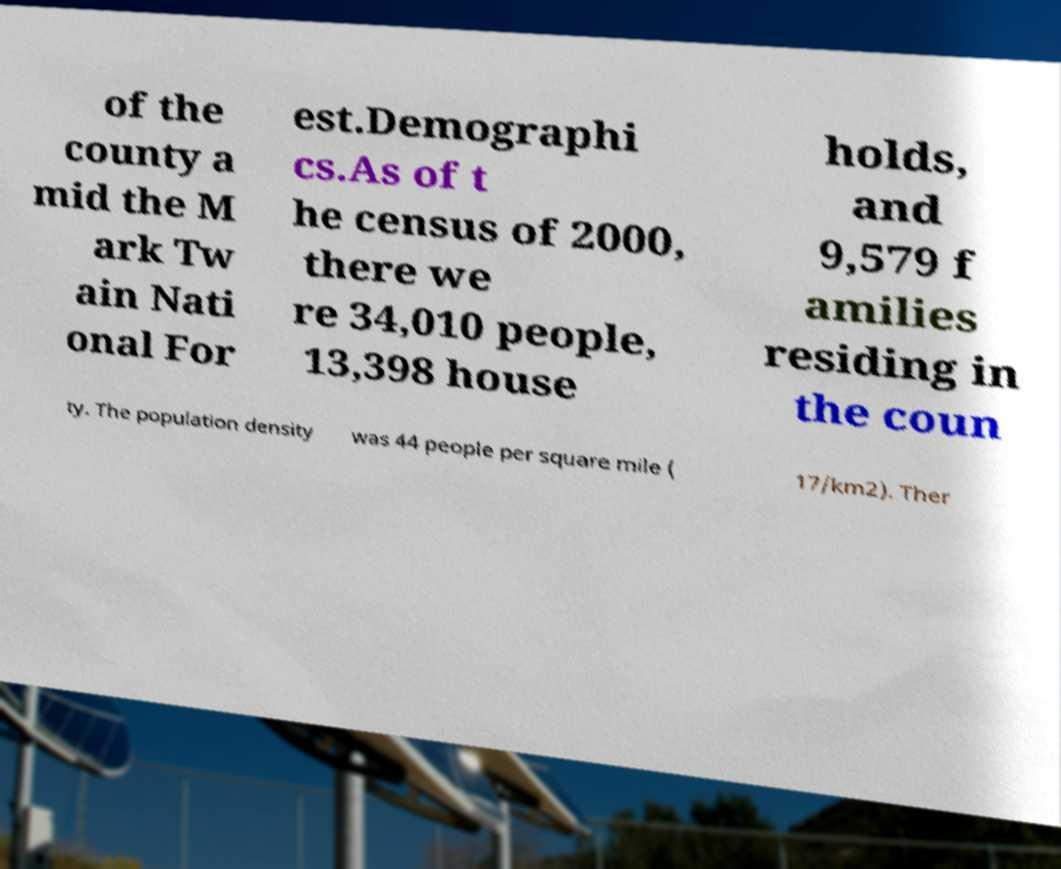I need the written content from this picture converted into text. Can you do that? of the county a mid the M ark Tw ain Nati onal For est.Demographi cs.As of t he census of 2000, there we re 34,010 people, 13,398 house holds, and 9,579 f amilies residing in the coun ty. The population density was 44 people per square mile ( 17/km2). Ther 